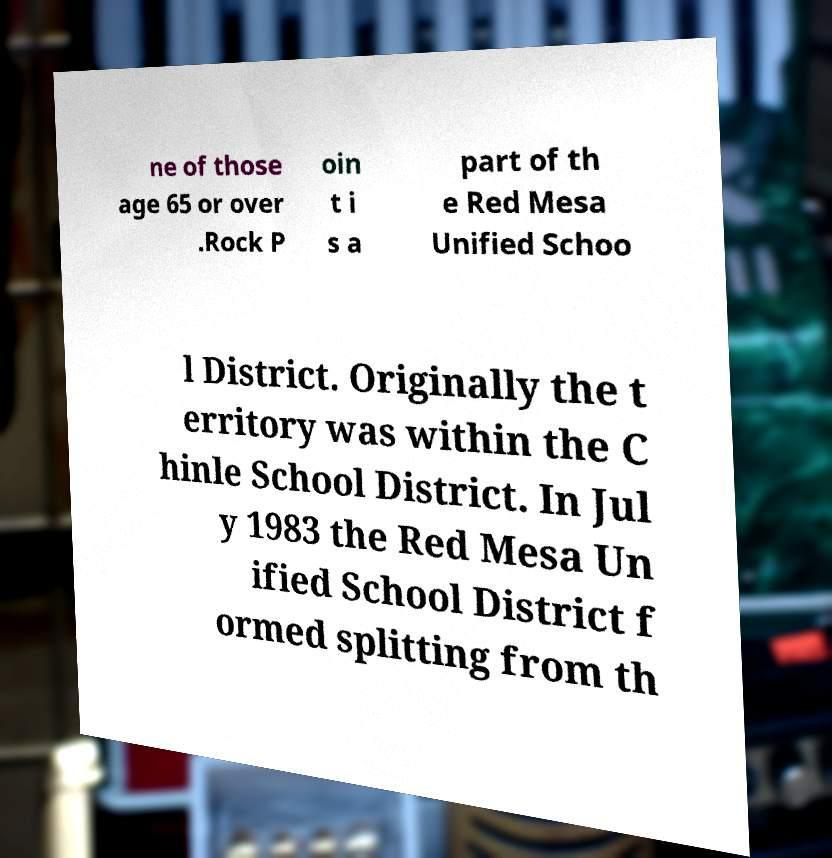What messages or text are displayed in this image? I need them in a readable, typed format. ne of those age 65 or over .Rock P oin t i s a part of th e Red Mesa Unified Schoo l District. Originally the t erritory was within the C hinle School District. In Jul y 1983 the Red Mesa Un ified School District f ormed splitting from th 